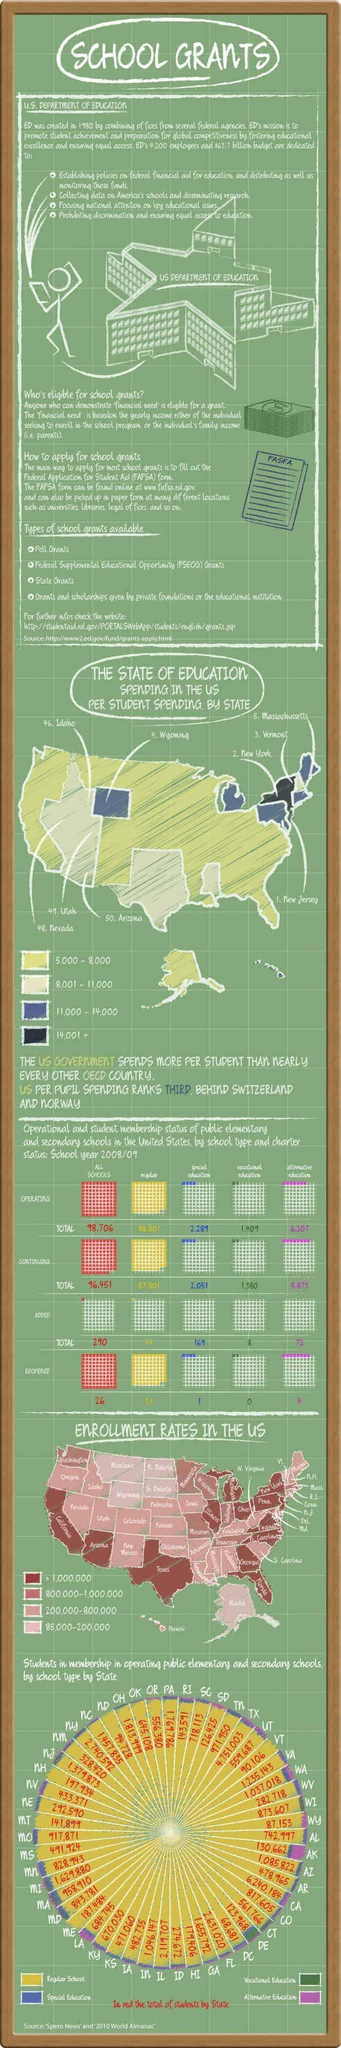How many types of school grants have been listed?
Answer the question with a short phrase. 4 